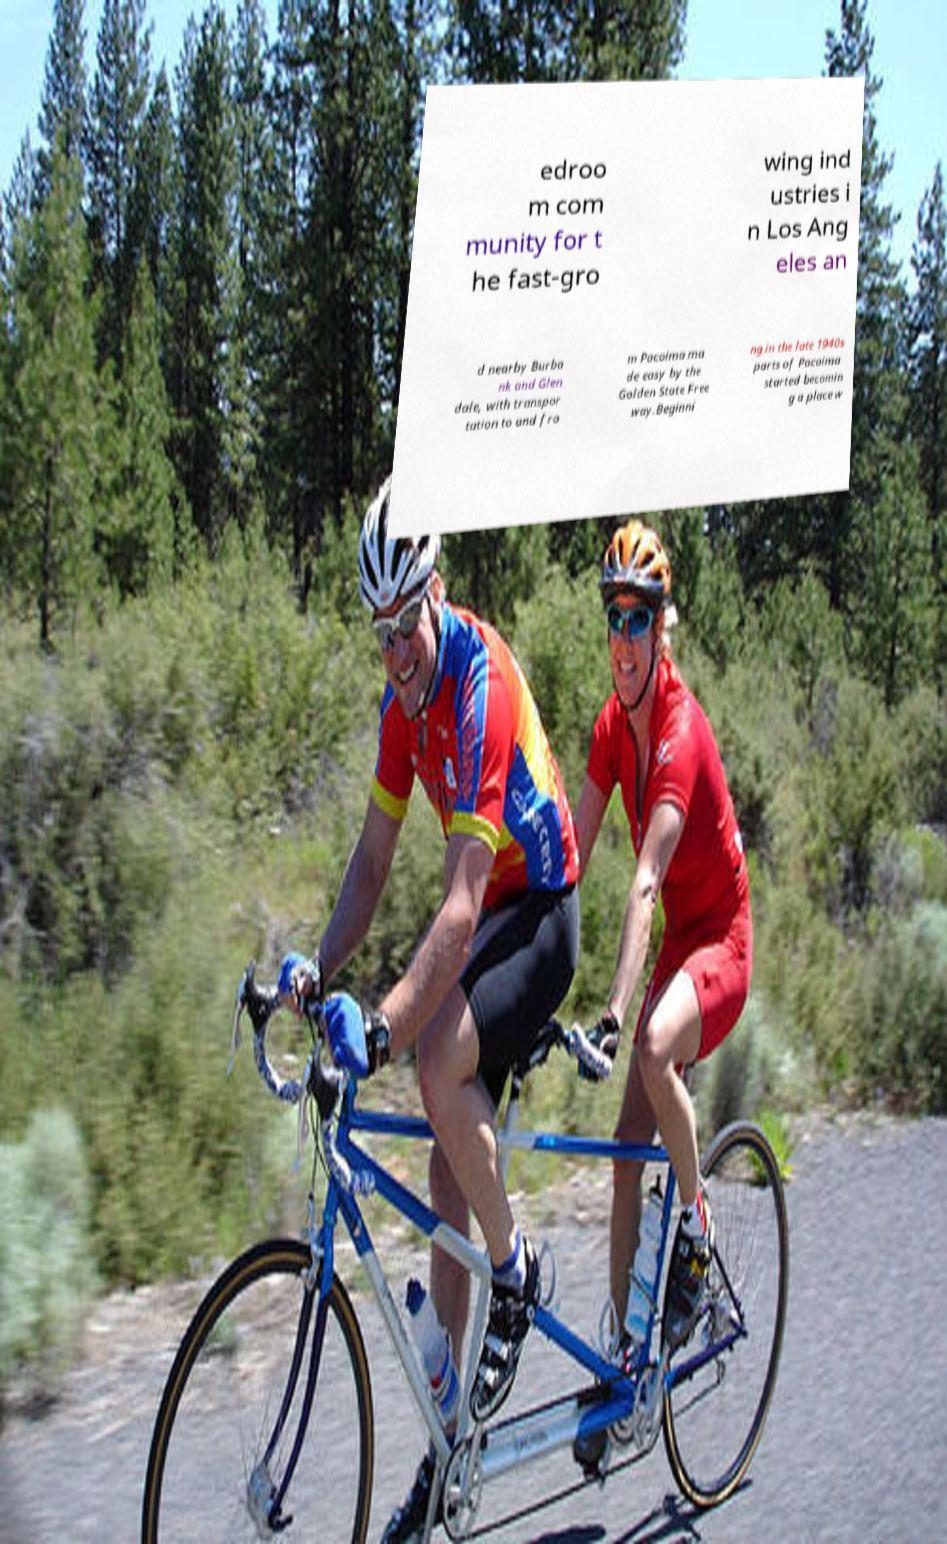There's text embedded in this image that I need extracted. Can you transcribe it verbatim? edroo m com munity for t he fast-gro wing ind ustries i n Los Ang eles an d nearby Burba nk and Glen dale, with transpor tation to and fro m Pacoima ma de easy by the Golden State Free way.Beginni ng in the late 1940s parts of Pacoima started becomin g a place w 